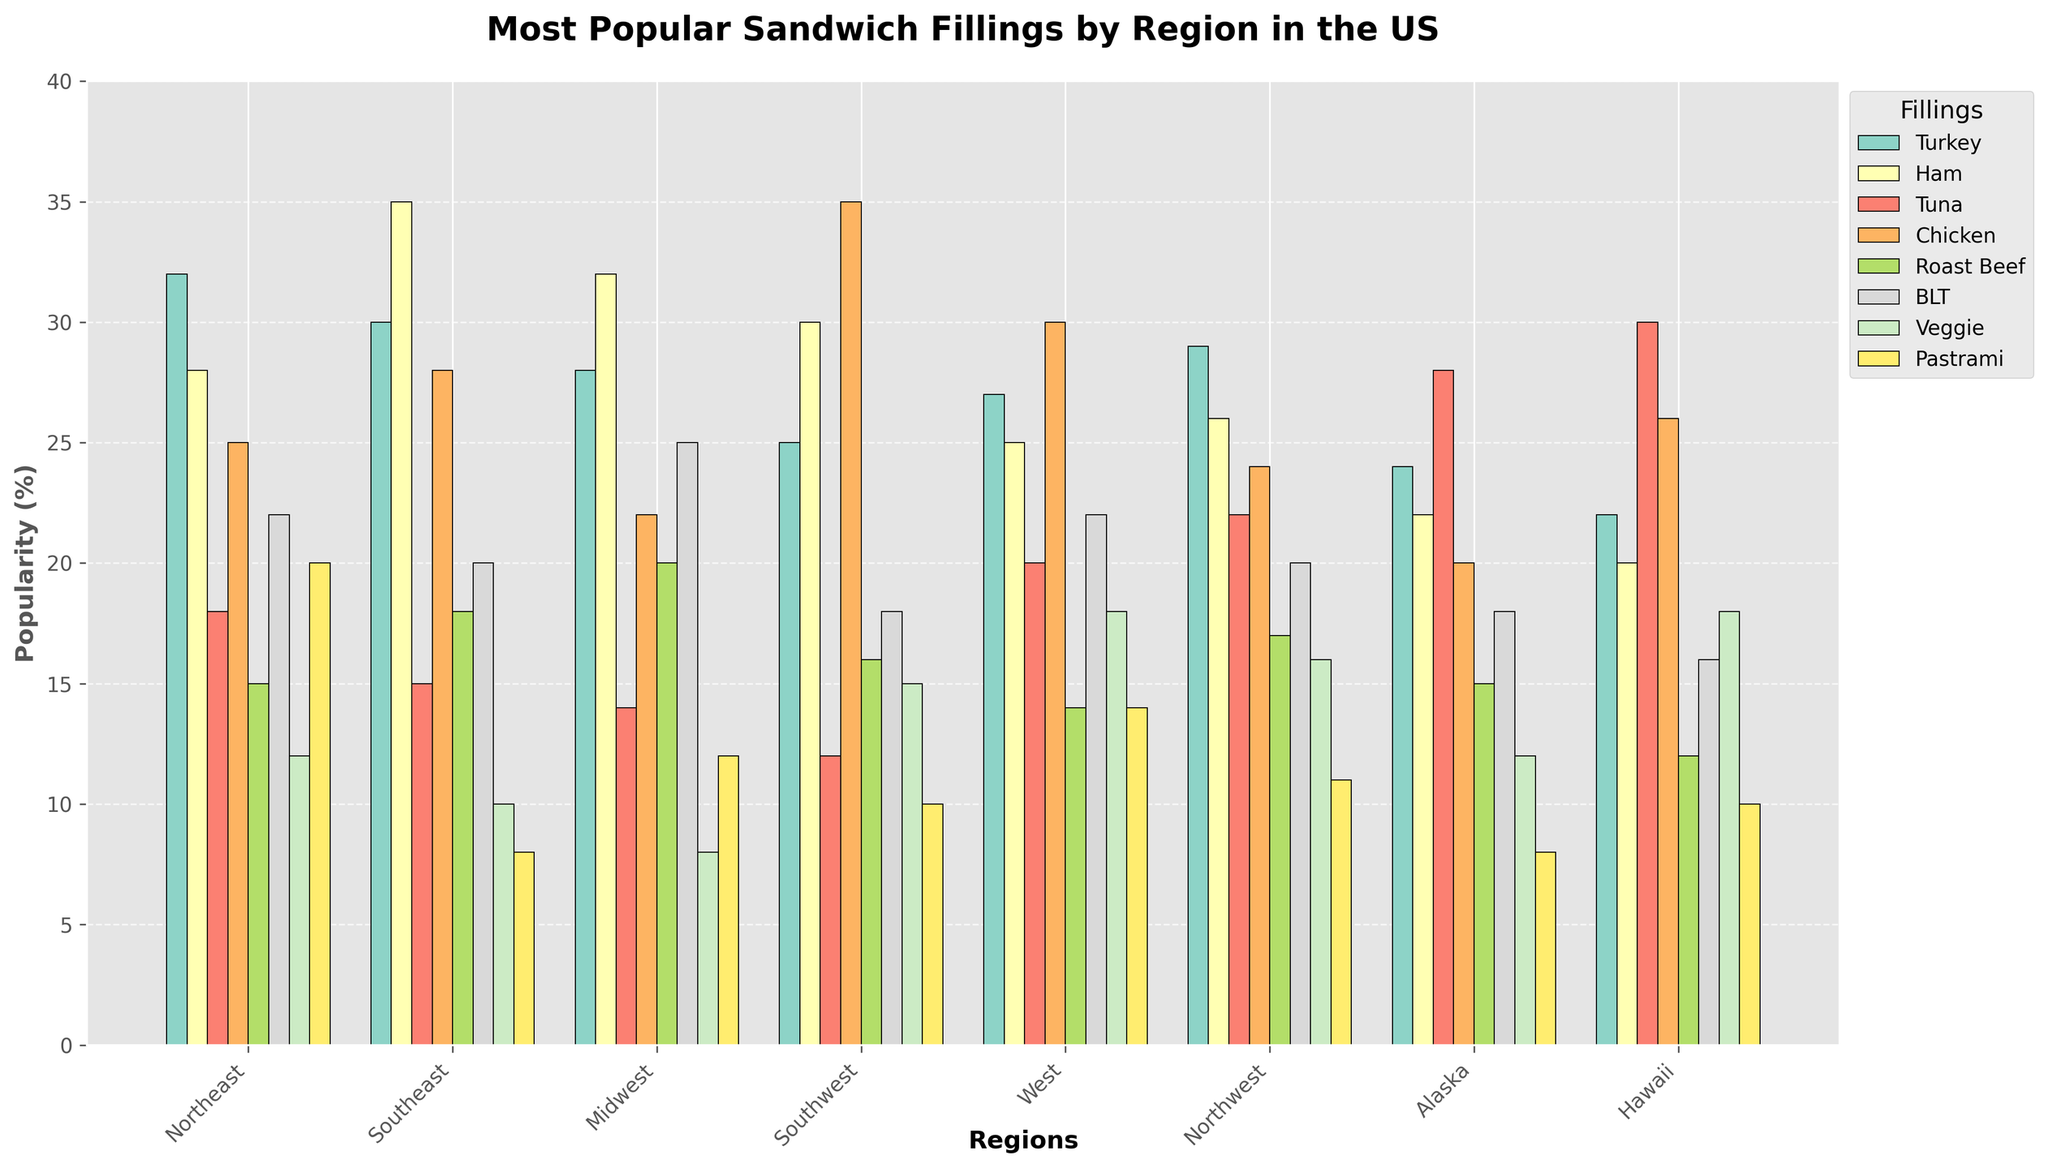What's the most popular sandwich filling in the Northeast? Looking at the bars corresponding to the Northeast region, the tallest bar indicates the most popular sandwich filling. In this case, the Turkey bar is the tallest.
Answer: Turkey Which region has the highest popularity percentage for Veggie sandwiches? To determine this, we compare the heights of the Veggie bars across all regions. The West region shows the tallest Veggie bar.
Answer: West What is the difference in the popularity of Tuna sandwiches between Alaska and Hawaii? From the figure, check the Tuna bars for Alaska and Hawaii. Alaska has 28% and Hawaii has 30%. Subtracting these values gives the difference. 30% - 28% = 2%
Answer: 2% In the Southwest, which sandwich filling is more popular, Chicken or Pastrami? Look at the bars for Chicken and Pastrami in the Southwest region. The Chicken bar is taller, showing a higher percentage.
Answer: Chicken Rank the sandwich fillings in the Midwest from most to least popular. For the Midwest region, arrange the sandwich fillings in descending order based on the bar heights. The ranking is as follows: Ham (32%), BLT (25%), Roast Beef (20%), Turkey (28%), Chicken (22%), Tuna (14%), Pastrami (12%), Veggie (8%).
Answer: Ham, BLT, Roast Beef, Turkey, Chicken, Tuna, Pastrami, Veggie Which region shows the highest popularity for Tuna sandwiches? Compare the Tuna bars across all the regions. Hawaii has the tallest Tuna bar, indicating the highest popularity.
Answer: Hawaii Calculate the average popularity of Chicken sandwiches across all regions. Add the Chicken values from all regions: 25 + 28 + 22 + 35 + 30 + 24 + 20 + 26 = 210. Then divide by the number of regions: 210 / 8 = 26.25%.
Answer: 26.25% In the West, compare the popularity of Turkey and BLT sandwiches. Which one is less popular? Observing the bars for Turkey and BLT in the West, the Turkey bar is slightly taller than the BLT bar, indicating BLT is less popular.
Answer: BLT How does the popularity of Pastrami in the Midwest compare to its popularity in the Northwest? From the figure, check the heights of the Pastrami bars in the Midwest and Northwest. Midwest has 12% and Northwest has 11%. Compare these values to find Midwest is slightly higher.
Answer: Midwest What is the total popularity percentage of Ham sandwiches across all regions? Sum the Ham values from all the regions: 28 + 35 + 32 + 30 + 25 + 26 + 22 + 20 = 218%.
Answer: 218% 